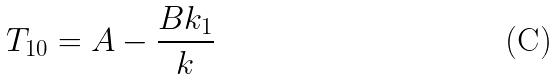<formula> <loc_0><loc_0><loc_500><loc_500>T _ { 1 0 } = A - \frac { B k _ { 1 } } { k }</formula> 